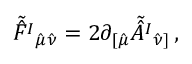Convert formula to latex. <formula><loc_0><loc_0><loc_500><loc_500>\tilde { \hat { F } ^ { I } _ { \hat { \mu } \hat { \nu } } = 2 \partial _ { [ \hat { \mu } } \tilde { \hat { A } ^ { I } _ { \hat { \nu } ] } \, ,</formula> 